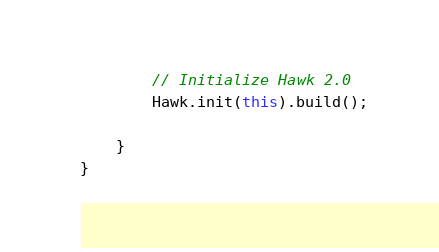<code> <loc_0><loc_0><loc_500><loc_500><_Java_>
        // Initialize Hawk 2.0
        Hawk.init(this).build();

    }
}
</code> 